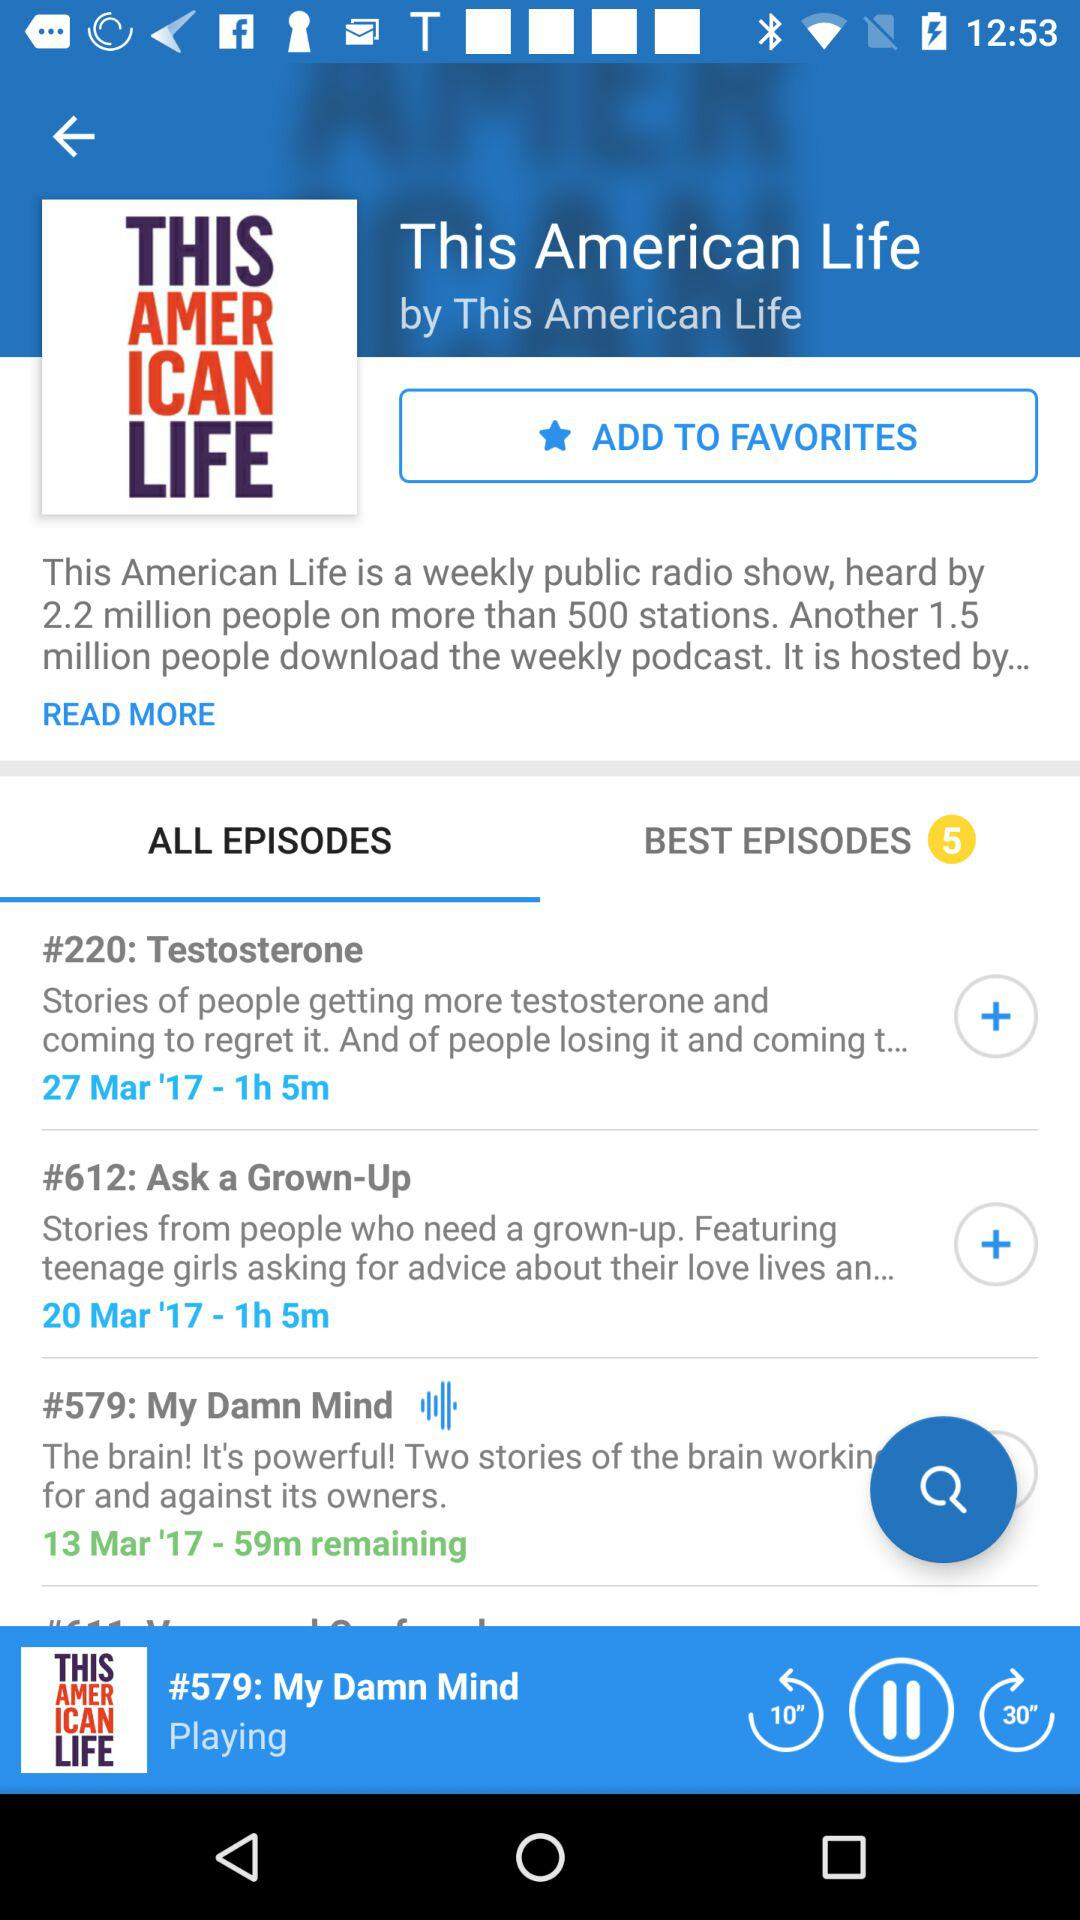How long is Episode 612? Episode 612 is 1 hour 5 minutes long. 